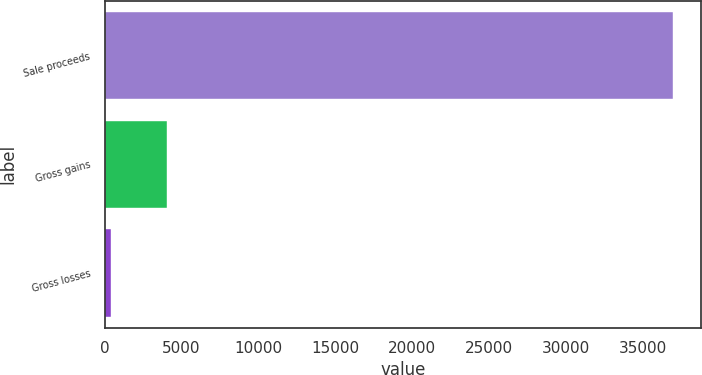Convert chart. <chart><loc_0><loc_0><loc_500><loc_500><bar_chart><fcel>Sale proceeds<fcel>Gross gains<fcel>Gross losses<nl><fcel>36956<fcel>4038.5<fcel>381<nl></chart> 